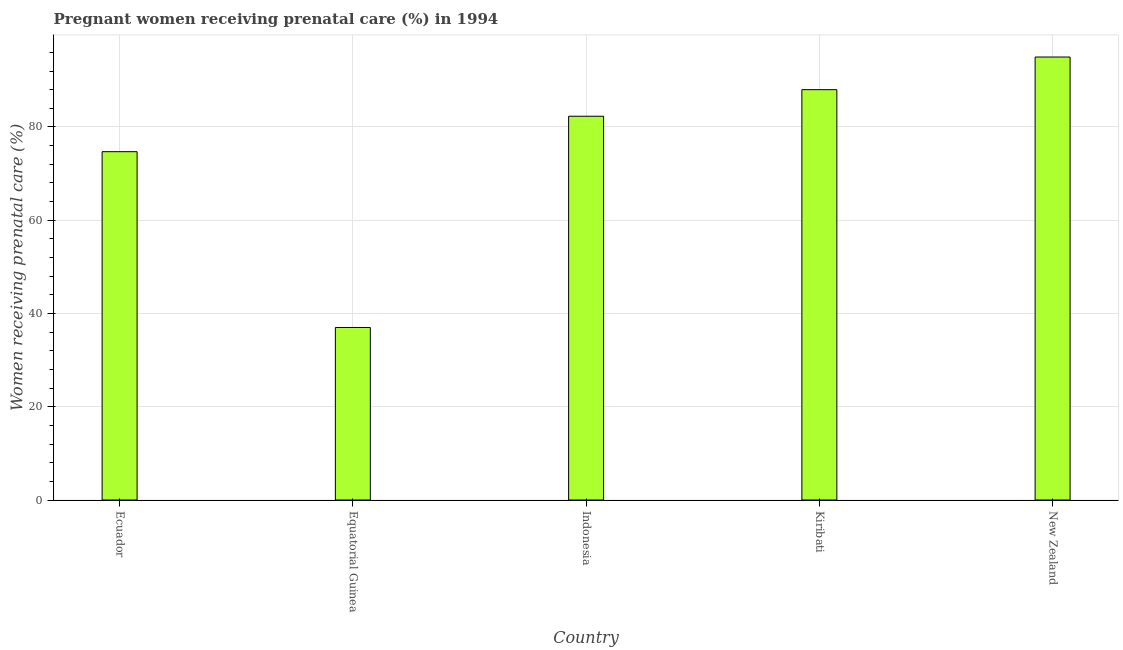Does the graph contain any zero values?
Give a very brief answer. No. What is the title of the graph?
Provide a short and direct response. Pregnant women receiving prenatal care (%) in 1994. What is the label or title of the X-axis?
Your answer should be compact. Country. What is the label or title of the Y-axis?
Your answer should be very brief. Women receiving prenatal care (%). Across all countries, what is the minimum percentage of pregnant women receiving prenatal care?
Provide a short and direct response. 37. In which country was the percentage of pregnant women receiving prenatal care maximum?
Offer a very short reply. New Zealand. In which country was the percentage of pregnant women receiving prenatal care minimum?
Keep it short and to the point. Equatorial Guinea. What is the sum of the percentage of pregnant women receiving prenatal care?
Give a very brief answer. 377. What is the difference between the percentage of pregnant women receiving prenatal care in Equatorial Guinea and Indonesia?
Ensure brevity in your answer.  -45.3. What is the average percentage of pregnant women receiving prenatal care per country?
Provide a short and direct response. 75.4. What is the median percentage of pregnant women receiving prenatal care?
Provide a succinct answer. 82.3. In how many countries, is the percentage of pregnant women receiving prenatal care greater than 48 %?
Make the answer very short. 4. What is the ratio of the percentage of pregnant women receiving prenatal care in Ecuador to that in Equatorial Guinea?
Offer a very short reply. 2.02. What is the difference between the highest and the second highest percentage of pregnant women receiving prenatal care?
Offer a terse response. 7. Is the sum of the percentage of pregnant women receiving prenatal care in Ecuador and Kiribati greater than the maximum percentage of pregnant women receiving prenatal care across all countries?
Your response must be concise. Yes. What is the difference between the highest and the lowest percentage of pregnant women receiving prenatal care?
Your answer should be compact. 58. In how many countries, is the percentage of pregnant women receiving prenatal care greater than the average percentage of pregnant women receiving prenatal care taken over all countries?
Make the answer very short. 3. Are all the bars in the graph horizontal?
Ensure brevity in your answer.  No. Are the values on the major ticks of Y-axis written in scientific E-notation?
Ensure brevity in your answer.  No. What is the Women receiving prenatal care (%) in Ecuador?
Offer a very short reply. 74.7. What is the Women receiving prenatal care (%) of Indonesia?
Your answer should be compact. 82.3. What is the Women receiving prenatal care (%) of Kiribati?
Provide a succinct answer. 88. What is the difference between the Women receiving prenatal care (%) in Ecuador and Equatorial Guinea?
Offer a terse response. 37.7. What is the difference between the Women receiving prenatal care (%) in Ecuador and Kiribati?
Give a very brief answer. -13.3. What is the difference between the Women receiving prenatal care (%) in Ecuador and New Zealand?
Provide a short and direct response. -20.3. What is the difference between the Women receiving prenatal care (%) in Equatorial Guinea and Indonesia?
Give a very brief answer. -45.3. What is the difference between the Women receiving prenatal care (%) in Equatorial Guinea and Kiribati?
Offer a terse response. -51. What is the difference between the Women receiving prenatal care (%) in Equatorial Guinea and New Zealand?
Keep it short and to the point. -58. What is the difference between the Women receiving prenatal care (%) in Indonesia and Kiribati?
Ensure brevity in your answer.  -5.7. What is the difference between the Women receiving prenatal care (%) in Indonesia and New Zealand?
Your response must be concise. -12.7. What is the ratio of the Women receiving prenatal care (%) in Ecuador to that in Equatorial Guinea?
Your response must be concise. 2.02. What is the ratio of the Women receiving prenatal care (%) in Ecuador to that in Indonesia?
Keep it short and to the point. 0.91. What is the ratio of the Women receiving prenatal care (%) in Ecuador to that in Kiribati?
Provide a succinct answer. 0.85. What is the ratio of the Women receiving prenatal care (%) in Ecuador to that in New Zealand?
Provide a short and direct response. 0.79. What is the ratio of the Women receiving prenatal care (%) in Equatorial Guinea to that in Indonesia?
Your response must be concise. 0.45. What is the ratio of the Women receiving prenatal care (%) in Equatorial Guinea to that in Kiribati?
Keep it short and to the point. 0.42. What is the ratio of the Women receiving prenatal care (%) in Equatorial Guinea to that in New Zealand?
Offer a very short reply. 0.39. What is the ratio of the Women receiving prenatal care (%) in Indonesia to that in Kiribati?
Offer a very short reply. 0.94. What is the ratio of the Women receiving prenatal care (%) in Indonesia to that in New Zealand?
Your answer should be very brief. 0.87. What is the ratio of the Women receiving prenatal care (%) in Kiribati to that in New Zealand?
Make the answer very short. 0.93. 